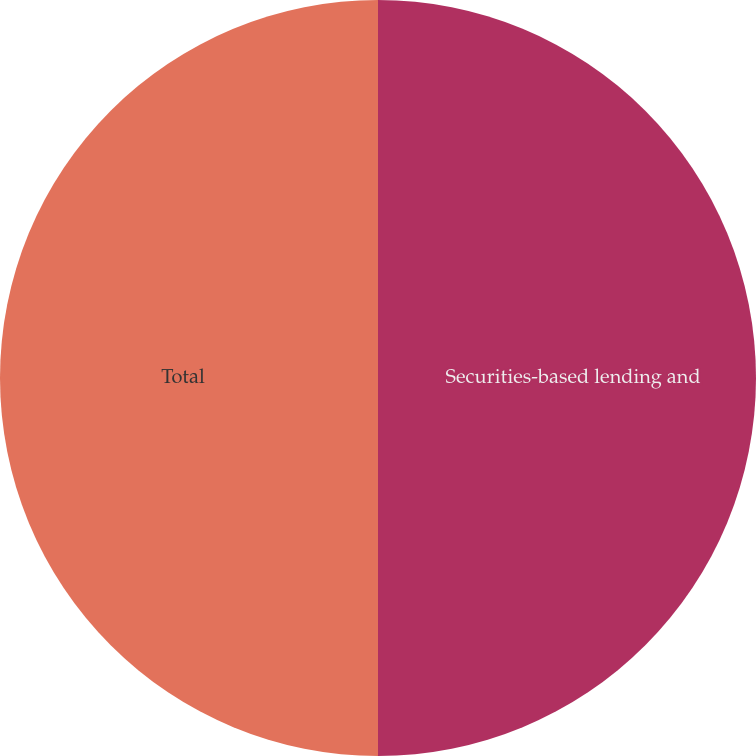Convert chart. <chart><loc_0><loc_0><loc_500><loc_500><pie_chart><fcel>Securities-based lending and<fcel>Total<nl><fcel>50.0%<fcel>50.0%<nl></chart> 